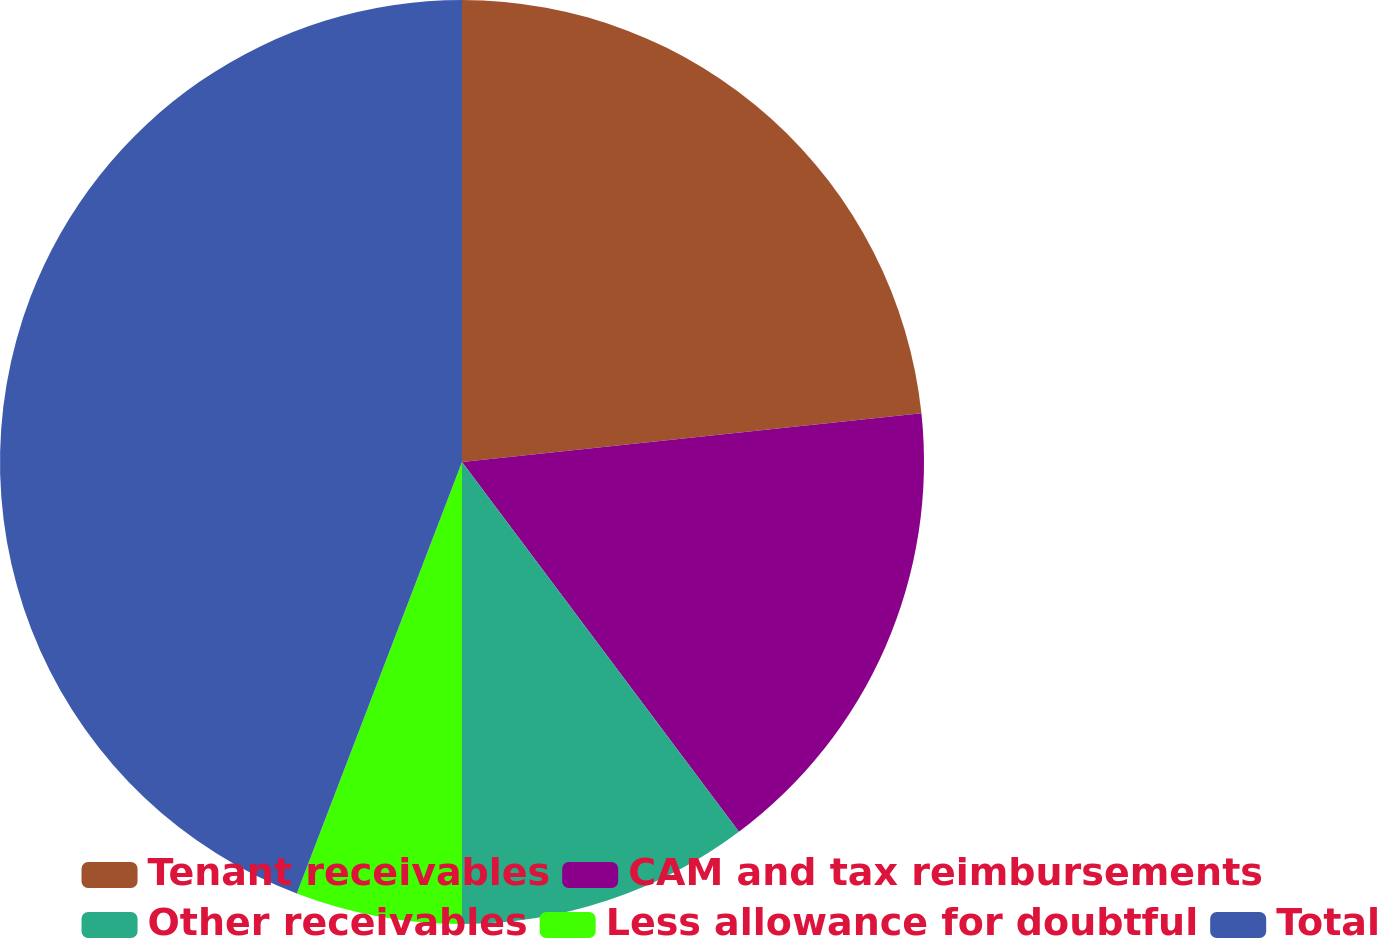Convert chart. <chart><loc_0><loc_0><loc_500><loc_500><pie_chart><fcel>Tenant receivables<fcel>CAM and tax reimbursements<fcel>Other receivables<fcel>Less allowance for doubtful<fcel>Total<nl><fcel>23.32%<fcel>16.45%<fcel>10.23%<fcel>5.82%<fcel>44.18%<nl></chart> 